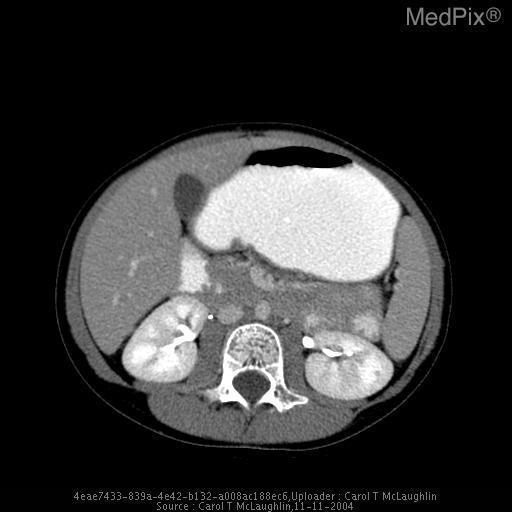Is the gall bladder enlarged?
Write a very short answer. No. Are both kidneys in view?
Answer briefly. Yes. Are both kidneys visible?
Write a very short answer. Yes. What is the muscle adjacent to the vertebrae?
Give a very brief answer. Psoas major muscle. What muscle surrounds the vertebrae?
Short answer required. Psoas major muscle. Is there oral contrast located in the colon?
Quick response, please. Yes. Is there oral contrast in the colon?
Quick response, please. Yes. 